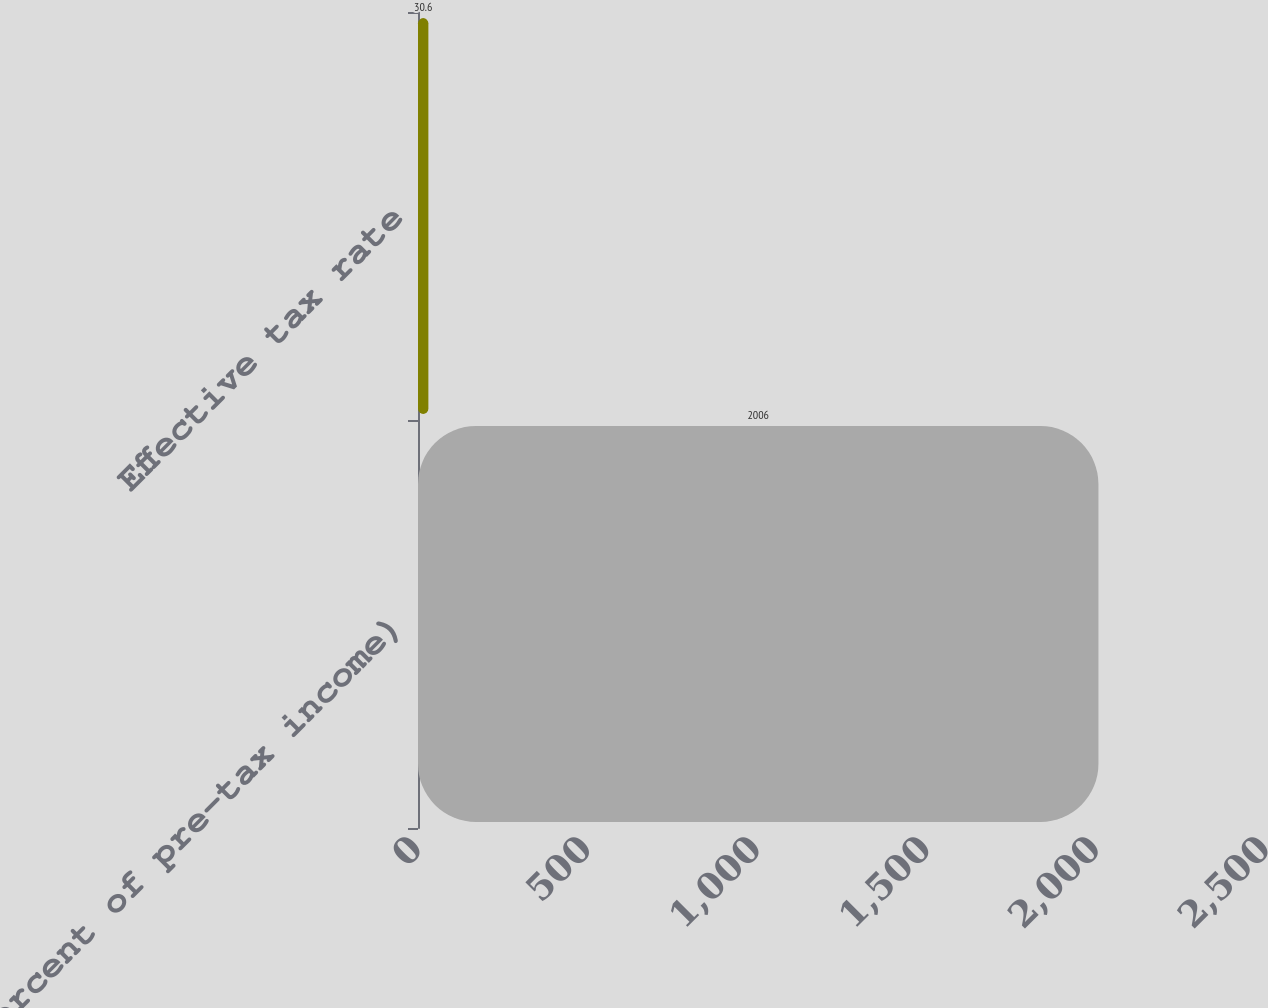Convert chart. <chart><loc_0><loc_0><loc_500><loc_500><bar_chart><fcel>(Percent of pre-tax income)<fcel>Effective tax rate<nl><fcel>2006<fcel>30.6<nl></chart> 